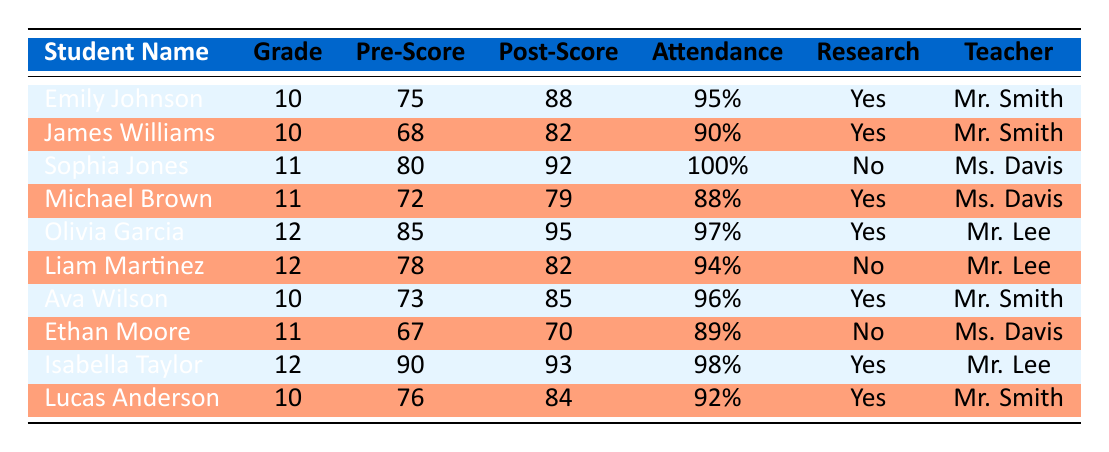What is the post-integration score of Emily Johnson? The table lists Emily Johnson's post-integration score in the appropriate column, which is 88.
Answer: 88 How many students participated in research? By reviewing the participation in research column, I can count the number of students with 'Yes'. There are 6 students who participated in research.
Answer: 6 What was the average attendance rate among the students? To calculate the average attendance rate, I add the attendance rates of all students: 95 + 90 + 100 + 88 + 97 + 94 + 96 + 89 + 98 + 92 = 929, and then divide by the number of students, which is 10. The average attendance rate is 929/10 = 92.9.
Answer: 92.9 Which student had the highest pre-integration score? By looking through the pre-integration score column, Olivia Garcia has the highest score of 85, which I can confirm as the maximum in the list.
Answer: Olivia Garcia Did Liam Martinez have a post-integration score higher than his pre-integration score? Comparing the post-integration score of Liam Martinez (82) with his pre-integration score (78), I see that 82 is greater than 78, indicating he improved.
Answer: Yes Which grade level had students with both the highest and lowest post-integration scores? The table shows that grade 12 has Olivia Garcia with the highest post-integration score (95) and Liam Martinez with the lowest (82). By examining other grade levels, I confirm that grade 12 had both the highest and lowest scores.
Answer: Grade 12 Which teacher reported the highest average post-integration score among their students? I will first find the post-integration scores for each teacher's students: Mr. Smith (88, 82, 85, 84) = average of 84.25, Ms. Davis (92, 79, 70) = average of 80.33, Mr. Lee (95, 82, 93) = average of 90. The highest average is 90 from Mr. Lee.
Answer: Mr. Lee How much has Michael Brown's score improved post-integration? To calculate the improvement for Michael Brown, I subtract his pre-integration score (72) from his post-integration score (79): 79 - 72 = 7. This shows his score improved by 7 points.
Answer: 7 Are there any students who did not participate in research but had a post-integration score above 80? By looking at the participation column and filtering for those who did not participate, I find that only Liam Martinez (82) fits the criteria, as his score is above 80.
Answer: Yes 